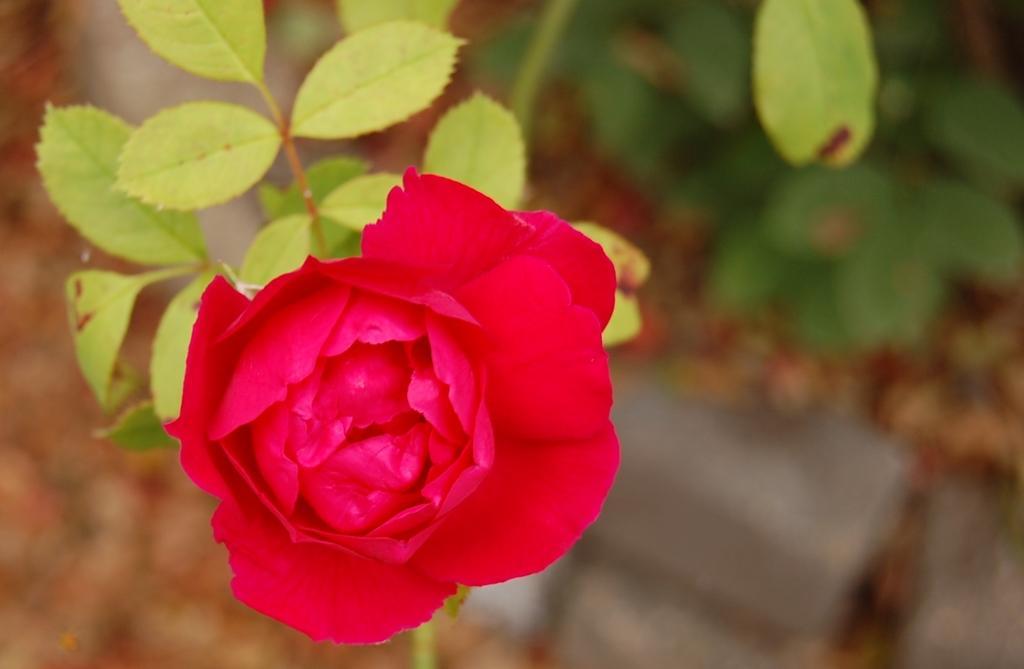Describe this image in one or two sentences. In the image there is a rose flower to a plant and below there is another plant on the land. 